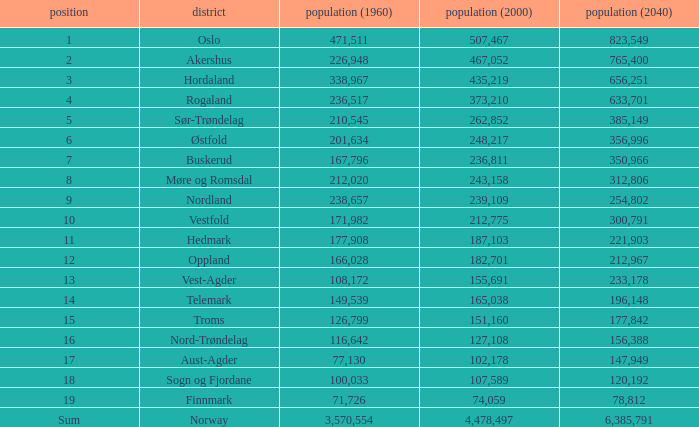What was the population of a county in 2040 that had a population less than 108,172 in 2000 and less than 107,589 in 1960? 2.0. 